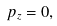Convert formula to latex. <formula><loc_0><loc_0><loc_500><loc_500>p _ { z } = 0 ,</formula> 